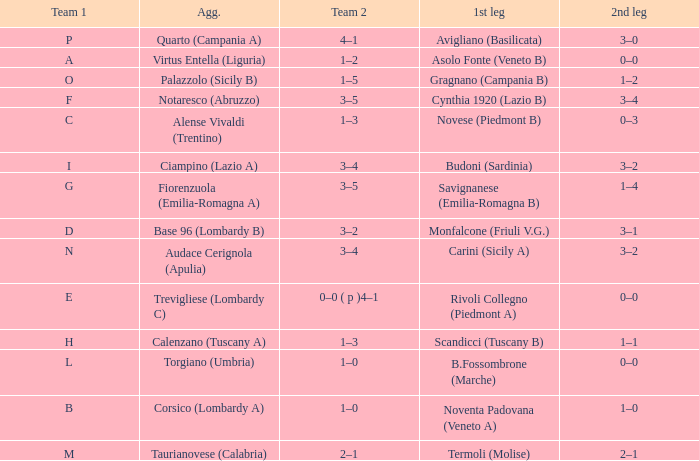What 1st leg has Alense Vivaldi (Trentino) as Agg.? Novese (Piedmont B). 